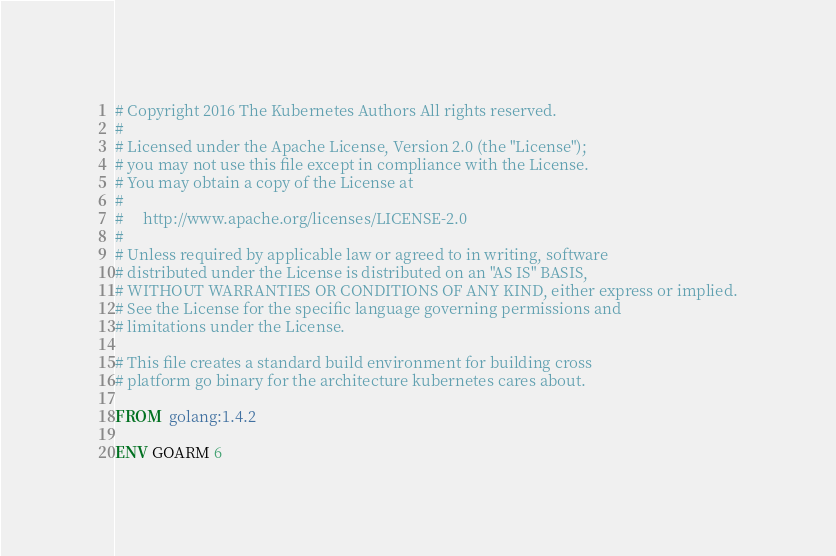Convert code to text. <code><loc_0><loc_0><loc_500><loc_500><_Dockerfile_># Copyright 2016 The Kubernetes Authors All rights reserved.
#
# Licensed under the Apache License, Version 2.0 (the "License");
# you may not use this file except in compliance with the License.
# You may obtain a copy of the License at
#
#     http://www.apache.org/licenses/LICENSE-2.0
#
# Unless required by applicable law or agreed to in writing, software
# distributed under the License is distributed on an "AS IS" BASIS,
# WITHOUT WARRANTIES OR CONDITIONS OF ANY KIND, either express or implied.
# See the License for the specific language governing permissions and
# limitations under the License.

# This file creates a standard build environment for building cross
# platform go binary for the architecture kubernetes cares about.

FROM  golang:1.4.2

ENV GOARM 6</code> 